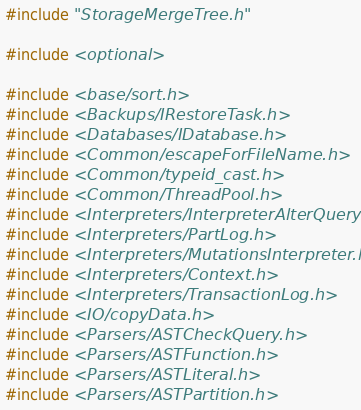<code> <loc_0><loc_0><loc_500><loc_500><_C++_>#include "StorageMergeTree.h"

#include <optional>

#include <base/sort.h>
#include <Backups/IRestoreTask.h>
#include <Databases/IDatabase.h>
#include <Common/escapeForFileName.h>
#include <Common/typeid_cast.h>
#include <Common/ThreadPool.h>
#include <Interpreters/InterpreterAlterQuery.h>
#include <Interpreters/PartLog.h>
#include <Interpreters/MutationsInterpreter.h>
#include <Interpreters/Context.h>
#include <Interpreters/TransactionLog.h>
#include <IO/copyData.h>
#include <Parsers/ASTCheckQuery.h>
#include <Parsers/ASTFunction.h>
#include <Parsers/ASTLiteral.h>
#include <Parsers/ASTPartition.h></code> 